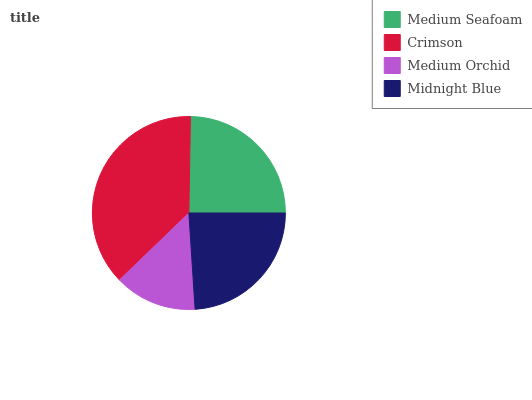Is Medium Orchid the minimum?
Answer yes or no. Yes. Is Crimson the maximum?
Answer yes or no. Yes. Is Crimson the minimum?
Answer yes or no. No. Is Medium Orchid the maximum?
Answer yes or no. No. Is Crimson greater than Medium Orchid?
Answer yes or no. Yes. Is Medium Orchid less than Crimson?
Answer yes or no. Yes. Is Medium Orchid greater than Crimson?
Answer yes or no. No. Is Crimson less than Medium Orchid?
Answer yes or no. No. Is Medium Seafoam the high median?
Answer yes or no. Yes. Is Midnight Blue the low median?
Answer yes or no. Yes. Is Medium Orchid the high median?
Answer yes or no. No. Is Crimson the low median?
Answer yes or no. No. 